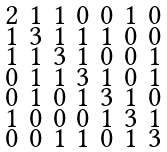Convert formula to latex. <formula><loc_0><loc_0><loc_500><loc_500>\begin{smallmatrix} 2 & 1 & 1 & 0 & 0 & 1 & 0 \\ 1 & 3 & 1 & 1 & 1 & 0 & 0 \\ 1 & 1 & 3 & 1 & 0 & 0 & 1 \\ 0 & 1 & 1 & 3 & 1 & 0 & 1 \\ 0 & 1 & 0 & 1 & 3 & 1 & 0 \\ 1 & 0 & 0 & 0 & 1 & 3 & 1 \\ 0 & 0 & 1 & 1 & 0 & 1 & 3 \end{smallmatrix}</formula> 